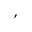<formula> <loc_0><loc_0><loc_500><loc_500>,</formula> 